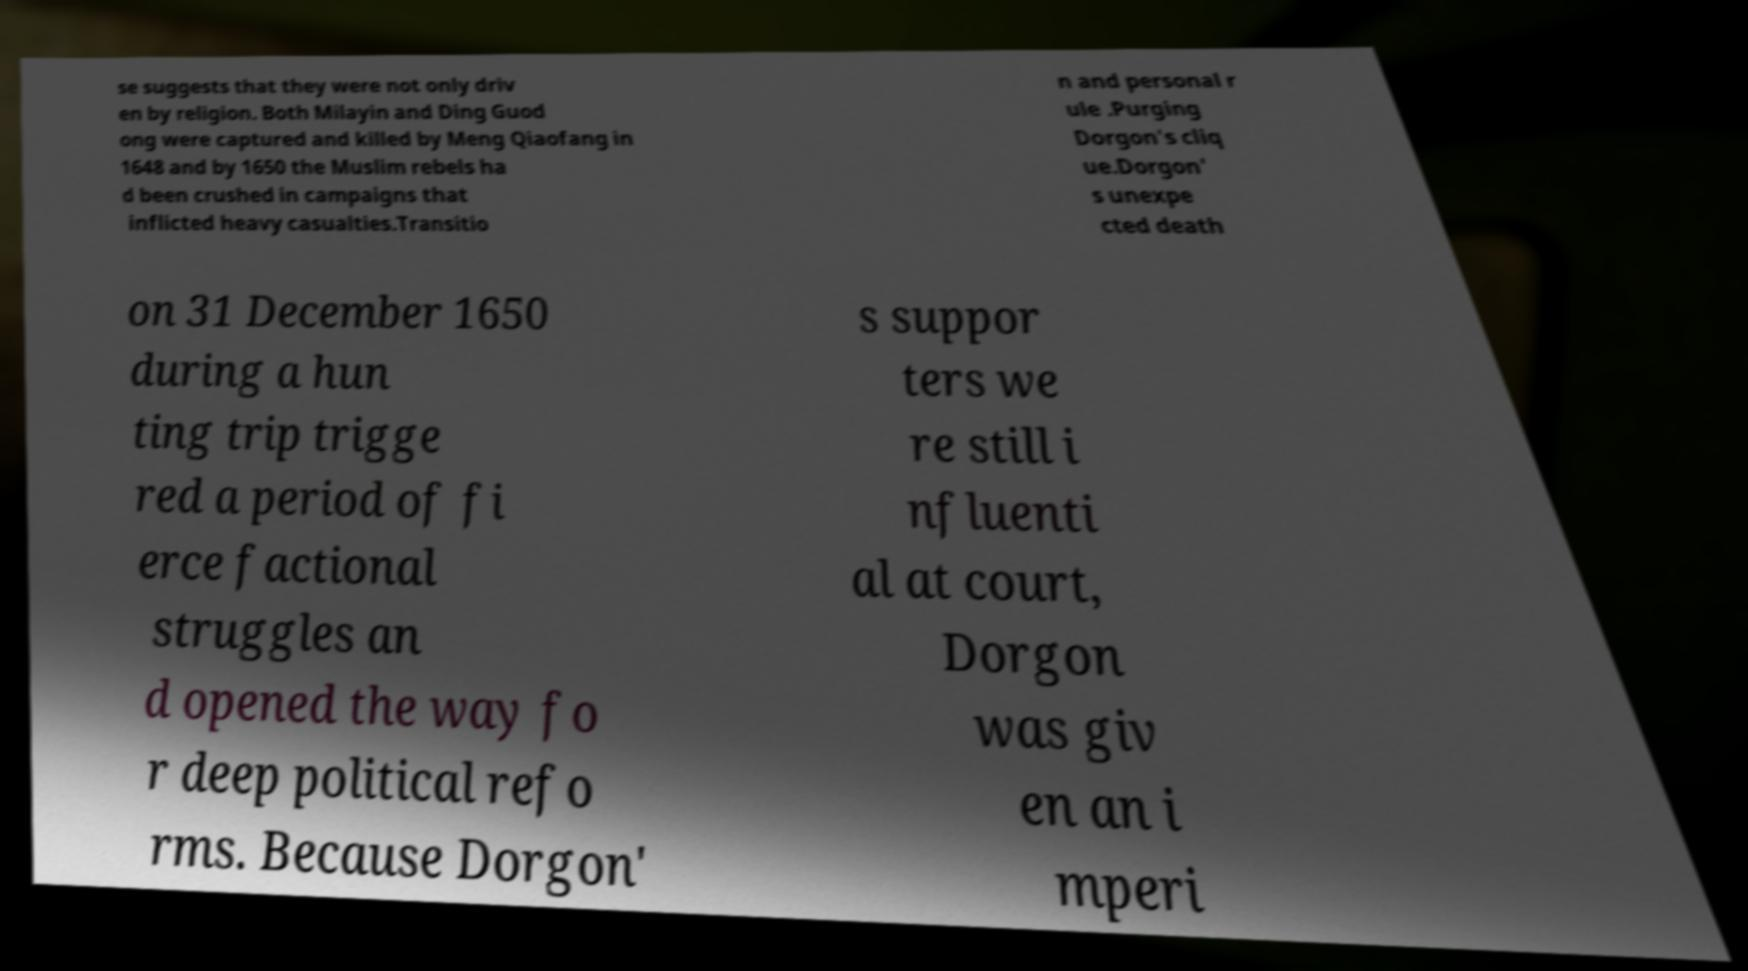Can you read and provide the text displayed in the image?This photo seems to have some interesting text. Can you extract and type it out for me? se suggests that they were not only driv en by religion. Both Milayin and Ding Guod ong were captured and killed by Meng Qiaofang in 1648 and by 1650 the Muslim rebels ha d been crushed in campaigns that inflicted heavy casualties.Transitio n and personal r ule .Purging Dorgon's cliq ue.Dorgon' s unexpe cted death on 31 December 1650 during a hun ting trip trigge red a period of fi erce factional struggles an d opened the way fo r deep political refo rms. Because Dorgon' s suppor ters we re still i nfluenti al at court, Dorgon was giv en an i mperi 